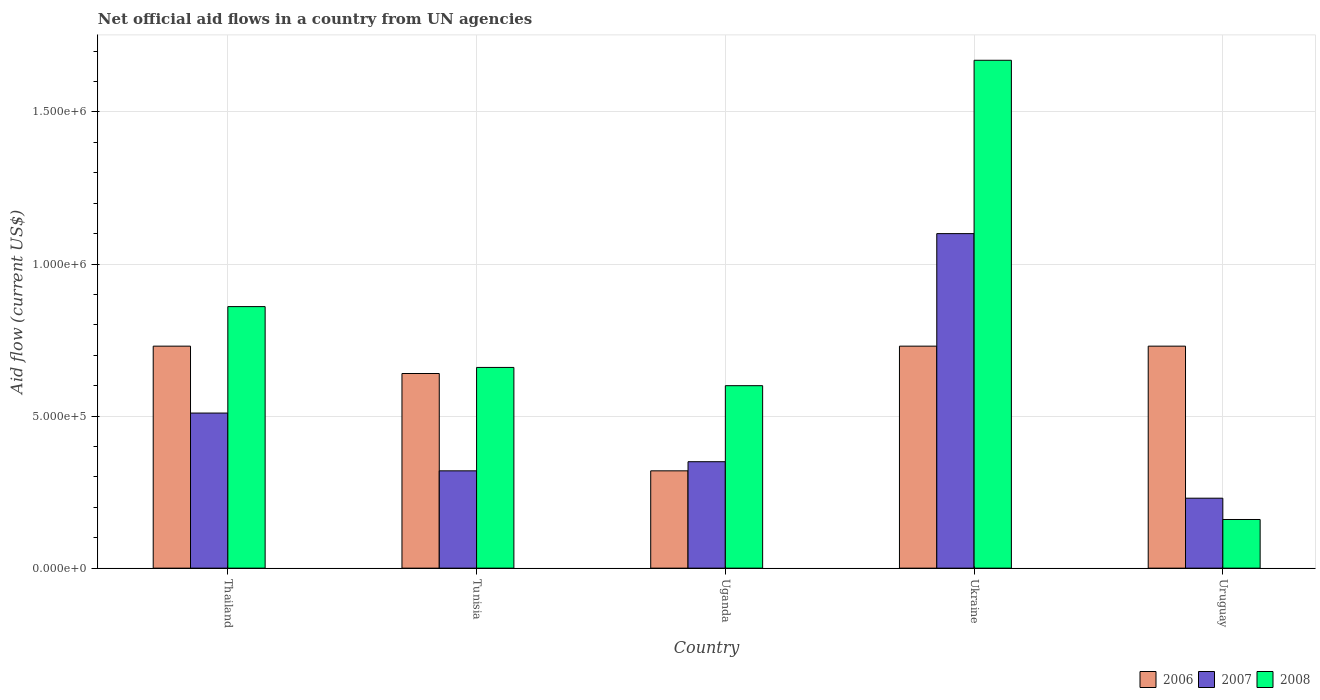How many different coloured bars are there?
Make the answer very short. 3. How many groups of bars are there?
Your response must be concise. 5. Are the number of bars on each tick of the X-axis equal?
Make the answer very short. Yes. How many bars are there on the 4th tick from the right?
Ensure brevity in your answer.  3. What is the label of the 1st group of bars from the left?
Give a very brief answer. Thailand. In how many cases, is the number of bars for a given country not equal to the number of legend labels?
Keep it short and to the point. 0. Across all countries, what is the maximum net official aid flow in 2006?
Provide a succinct answer. 7.30e+05. Across all countries, what is the minimum net official aid flow in 2007?
Provide a short and direct response. 2.30e+05. In which country was the net official aid flow in 2008 maximum?
Ensure brevity in your answer.  Ukraine. In which country was the net official aid flow in 2007 minimum?
Make the answer very short. Uruguay. What is the total net official aid flow in 2006 in the graph?
Your answer should be very brief. 3.15e+06. What is the difference between the net official aid flow in 2007 in Uganda and that in Ukraine?
Your answer should be very brief. -7.50e+05. What is the difference between the net official aid flow in 2008 in Ukraine and the net official aid flow in 2006 in Uganda?
Ensure brevity in your answer.  1.35e+06. What is the average net official aid flow in 2006 per country?
Your response must be concise. 6.30e+05. Is the net official aid flow in 2008 in Uganda less than that in Uruguay?
Offer a terse response. No. What is the difference between the highest and the second highest net official aid flow in 2008?
Provide a succinct answer. 1.01e+06. Is the sum of the net official aid flow in 2008 in Thailand and Tunisia greater than the maximum net official aid flow in 2006 across all countries?
Ensure brevity in your answer.  Yes. What does the 1st bar from the right in Thailand represents?
Offer a very short reply. 2008. How many bars are there?
Provide a succinct answer. 15. Are all the bars in the graph horizontal?
Your answer should be compact. No. What is the difference between two consecutive major ticks on the Y-axis?
Ensure brevity in your answer.  5.00e+05. Are the values on the major ticks of Y-axis written in scientific E-notation?
Make the answer very short. Yes. Does the graph contain any zero values?
Ensure brevity in your answer.  No. Does the graph contain grids?
Offer a terse response. Yes. What is the title of the graph?
Your answer should be very brief. Net official aid flows in a country from UN agencies. What is the label or title of the X-axis?
Make the answer very short. Country. What is the label or title of the Y-axis?
Offer a very short reply. Aid flow (current US$). What is the Aid flow (current US$) in 2006 in Thailand?
Your answer should be very brief. 7.30e+05. What is the Aid flow (current US$) of 2007 in Thailand?
Provide a succinct answer. 5.10e+05. What is the Aid flow (current US$) of 2008 in Thailand?
Give a very brief answer. 8.60e+05. What is the Aid flow (current US$) of 2006 in Tunisia?
Your response must be concise. 6.40e+05. What is the Aid flow (current US$) of 2007 in Tunisia?
Your response must be concise. 3.20e+05. What is the Aid flow (current US$) in 2008 in Tunisia?
Your answer should be compact. 6.60e+05. What is the Aid flow (current US$) of 2007 in Uganda?
Make the answer very short. 3.50e+05. What is the Aid flow (current US$) in 2006 in Ukraine?
Your answer should be very brief. 7.30e+05. What is the Aid flow (current US$) of 2007 in Ukraine?
Provide a succinct answer. 1.10e+06. What is the Aid flow (current US$) of 2008 in Ukraine?
Offer a terse response. 1.67e+06. What is the Aid flow (current US$) of 2006 in Uruguay?
Provide a succinct answer. 7.30e+05. What is the Aid flow (current US$) in 2007 in Uruguay?
Offer a terse response. 2.30e+05. What is the Aid flow (current US$) of 2008 in Uruguay?
Give a very brief answer. 1.60e+05. Across all countries, what is the maximum Aid flow (current US$) of 2006?
Provide a short and direct response. 7.30e+05. Across all countries, what is the maximum Aid flow (current US$) of 2007?
Offer a very short reply. 1.10e+06. Across all countries, what is the maximum Aid flow (current US$) in 2008?
Give a very brief answer. 1.67e+06. Across all countries, what is the minimum Aid flow (current US$) in 2008?
Offer a very short reply. 1.60e+05. What is the total Aid flow (current US$) of 2006 in the graph?
Provide a succinct answer. 3.15e+06. What is the total Aid flow (current US$) in 2007 in the graph?
Give a very brief answer. 2.51e+06. What is the total Aid flow (current US$) of 2008 in the graph?
Offer a very short reply. 3.95e+06. What is the difference between the Aid flow (current US$) in 2006 in Thailand and that in Tunisia?
Give a very brief answer. 9.00e+04. What is the difference between the Aid flow (current US$) of 2007 in Thailand and that in Tunisia?
Keep it short and to the point. 1.90e+05. What is the difference between the Aid flow (current US$) in 2008 in Thailand and that in Tunisia?
Provide a short and direct response. 2.00e+05. What is the difference between the Aid flow (current US$) in 2007 in Thailand and that in Uganda?
Your answer should be compact. 1.60e+05. What is the difference between the Aid flow (current US$) of 2008 in Thailand and that in Uganda?
Provide a short and direct response. 2.60e+05. What is the difference between the Aid flow (current US$) in 2006 in Thailand and that in Ukraine?
Provide a short and direct response. 0. What is the difference between the Aid flow (current US$) in 2007 in Thailand and that in Ukraine?
Offer a terse response. -5.90e+05. What is the difference between the Aid flow (current US$) of 2008 in Thailand and that in Ukraine?
Give a very brief answer. -8.10e+05. What is the difference between the Aid flow (current US$) in 2008 in Thailand and that in Uruguay?
Give a very brief answer. 7.00e+05. What is the difference between the Aid flow (current US$) in 2006 in Tunisia and that in Uganda?
Give a very brief answer. 3.20e+05. What is the difference between the Aid flow (current US$) of 2007 in Tunisia and that in Uganda?
Make the answer very short. -3.00e+04. What is the difference between the Aid flow (current US$) of 2007 in Tunisia and that in Ukraine?
Ensure brevity in your answer.  -7.80e+05. What is the difference between the Aid flow (current US$) in 2008 in Tunisia and that in Ukraine?
Make the answer very short. -1.01e+06. What is the difference between the Aid flow (current US$) of 2007 in Tunisia and that in Uruguay?
Ensure brevity in your answer.  9.00e+04. What is the difference between the Aid flow (current US$) in 2006 in Uganda and that in Ukraine?
Provide a short and direct response. -4.10e+05. What is the difference between the Aid flow (current US$) of 2007 in Uganda and that in Ukraine?
Give a very brief answer. -7.50e+05. What is the difference between the Aid flow (current US$) of 2008 in Uganda and that in Ukraine?
Make the answer very short. -1.07e+06. What is the difference between the Aid flow (current US$) of 2006 in Uganda and that in Uruguay?
Provide a short and direct response. -4.10e+05. What is the difference between the Aid flow (current US$) in 2008 in Uganda and that in Uruguay?
Provide a succinct answer. 4.40e+05. What is the difference between the Aid flow (current US$) of 2006 in Ukraine and that in Uruguay?
Your response must be concise. 0. What is the difference between the Aid flow (current US$) of 2007 in Ukraine and that in Uruguay?
Your response must be concise. 8.70e+05. What is the difference between the Aid flow (current US$) of 2008 in Ukraine and that in Uruguay?
Your answer should be very brief. 1.51e+06. What is the difference between the Aid flow (current US$) in 2006 in Thailand and the Aid flow (current US$) in 2007 in Tunisia?
Make the answer very short. 4.10e+05. What is the difference between the Aid flow (current US$) of 2007 in Thailand and the Aid flow (current US$) of 2008 in Tunisia?
Provide a short and direct response. -1.50e+05. What is the difference between the Aid flow (current US$) in 2006 in Thailand and the Aid flow (current US$) in 2008 in Uganda?
Give a very brief answer. 1.30e+05. What is the difference between the Aid flow (current US$) in 2006 in Thailand and the Aid flow (current US$) in 2007 in Ukraine?
Your answer should be very brief. -3.70e+05. What is the difference between the Aid flow (current US$) of 2006 in Thailand and the Aid flow (current US$) of 2008 in Ukraine?
Give a very brief answer. -9.40e+05. What is the difference between the Aid flow (current US$) of 2007 in Thailand and the Aid flow (current US$) of 2008 in Ukraine?
Keep it short and to the point. -1.16e+06. What is the difference between the Aid flow (current US$) of 2006 in Thailand and the Aid flow (current US$) of 2008 in Uruguay?
Your answer should be very brief. 5.70e+05. What is the difference between the Aid flow (current US$) of 2007 in Thailand and the Aid flow (current US$) of 2008 in Uruguay?
Ensure brevity in your answer.  3.50e+05. What is the difference between the Aid flow (current US$) in 2006 in Tunisia and the Aid flow (current US$) in 2008 in Uganda?
Your answer should be very brief. 4.00e+04. What is the difference between the Aid flow (current US$) of 2007 in Tunisia and the Aid flow (current US$) of 2008 in Uganda?
Provide a succinct answer. -2.80e+05. What is the difference between the Aid flow (current US$) in 2006 in Tunisia and the Aid flow (current US$) in 2007 in Ukraine?
Your response must be concise. -4.60e+05. What is the difference between the Aid flow (current US$) of 2006 in Tunisia and the Aid flow (current US$) of 2008 in Ukraine?
Provide a short and direct response. -1.03e+06. What is the difference between the Aid flow (current US$) in 2007 in Tunisia and the Aid flow (current US$) in 2008 in Ukraine?
Ensure brevity in your answer.  -1.35e+06. What is the difference between the Aid flow (current US$) of 2006 in Tunisia and the Aid flow (current US$) of 2007 in Uruguay?
Offer a terse response. 4.10e+05. What is the difference between the Aid flow (current US$) in 2006 in Tunisia and the Aid flow (current US$) in 2008 in Uruguay?
Give a very brief answer. 4.80e+05. What is the difference between the Aid flow (current US$) of 2006 in Uganda and the Aid flow (current US$) of 2007 in Ukraine?
Give a very brief answer. -7.80e+05. What is the difference between the Aid flow (current US$) of 2006 in Uganda and the Aid flow (current US$) of 2008 in Ukraine?
Your answer should be very brief. -1.35e+06. What is the difference between the Aid flow (current US$) in 2007 in Uganda and the Aid flow (current US$) in 2008 in Ukraine?
Make the answer very short. -1.32e+06. What is the difference between the Aid flow (current US$) of 2006 in Ukraine and the Aid flow (current US$) of 2008 in Uruguay?
Your answer should be very brief. 5.70e+05. What is the difference between the Aid flow (current US$) in 2007 in Ukraine and the Aid flow (current US$) in 2008 in Uruguay?
Your answer should be compact. 9.40e+05. What is the average Aid flow (current US$) of 2006 per country?
Your answer should be very brief. 6.30e+05. What is the average Aid flow (current US$) of 2007 per country?
Your answer should be very brief. 5.02e+05. What is the average Aid flow (current US$) of 2008 per country?
Provide a short and direct response. 7.90e+05. What is the difference between the Aid flow (current US$) of 2006 and Aid flow (current US$) of 2007 in Thailand?
Give a very brief answer. 2.20e+05. What is the difference between the Aid flow (current US$) of 2007 and Aid flow (current US$) of 2008 in Thailand?
Keep it short and to the point. -3.50e+05. What is the difference between the Aid flow (current US$) in 2006 and Aid flow (current US$) in 2007 in Tunisia?
Offer a terse response. 3.20e+05. What is the difference between the Aid flow (current US$) of 2006 and Aid flow (current US$) of 2008 in Tunisia?
Your answer should be compact. -2.00e+04. What is the difference between the Aid flow (current US$) of 2007 and Aid flow (current US$) of 2008 in Tunisia?
Provide a short and direct response. -3.40e+05. What is the difference between the Aid flow (current US$) in 2006 and Aid flow (current US$) in 2007 in Uganda?
Provide a succinct answer. -3.00e+04. What is the difference between the Aid flow (current US$) of 2006 and Aid flow (current US$) of 2008 in Uganda?
Your answer should be compact. -2.80e+05. What is the difference between the Aid flow (current US$) of 2006 and Aid flow (current US$) of 2007 in Ukraine?
Offer a terse response. -3.70e+05. What is the difference between the Aid flow (current US$) in 2006 and Aid flow (current US$) in 2008 in Ukraine?
Your answer should be very brief. -9.40e+05. What is the difference between the Aid flow (current US$) in 2007 and Aid flow (current US$) in 2008 in Ukraine?
Your answer should be very brief. -5.70e+05. What is the difference between the Aid flow (current US$) in 2006 and Aid flow (current US$) in 2007 in Uruguay?
Offer a terse response. 5.00e+05. What is the difference between the Aid flow (current US$) of 2006 and Aid flow (current US$) of 2008 in Uruguay?
Make the answer very short. 5.70e+05. What is the ratio of the Aid flow (current US$) in 2006 in Thailand to that in Tunisia?
Ensure brevity in your answer.  1.14. What is the ratio of the Aid flow (current US$) of 2007 in Thailand to that in Tunisia?
Your answer should be very brief. 1.59. What is the ratio of the Aid flow (current US$) of 2008 in Thailand to that in Tunisia?
Your answer should be compact. 1.3. What is the ratio of the Aid flow (current US$) of 2006 in Thailand to that in Uganda?
Ensure brevity in your answer.  2.28. What is the ratio of the Aid flow (current US$) of 2007 in Thailand to that in Uganda?
Your answer should be very brief. 1.46. What is the ratio of the Aid flow (current US$) of 2008 in Thailand to that in Uganda?
Your answer should be compact. 1.43. What is the ratio of the Aid flow (current US$) of 2006 in Thailand to that in Ukraine?
Your answer should be compact. 1. What is the ratio of the Aid flow (current US$) in 2007 in Thailand to that in Ukraine?
Provide a succinct answer. 0.46. What is the ratio of the Aid flow (current US$) in 2008 in Thailand to that in Ukraine?
Your answer should be very brief. 0.52. What is the ratio of the Aid flow (current US$) in 2007 in Thailand to that in Uruguay?
Offer a very short reply. 2.22. What is the ratio of the Aid flow (current US$) in 2008 in Thailand to that in Uruguay?
Offer a very short reply. 5.38. What is the ratio of the Aid flow (current US$) in 2006 in Tunisia to that in Uganda?
Your response must be concise. 2. What is the ratio of the Aid flow (current US$) in 2007 in Tunisia to that in Uganda?
Offer a terse response. 0.91. What is the ratio of the Aid flow (current US$) in 2008 in Tunisia to that in Uganda?
Ensure brevity in your answer.  1.1. What is the ratio of the Aid flow (current US$) in 2006 in Tunisia to that in Ukraine?
Provide a short and direct response. 0.88. What is the ratio of the Aid flow (current US$) of 2007 in Tunisia to that in Ukraine?
Keep it short and to the point. 0.29. What is the ratio of the Aid flow (current US$) of 2008 in Tunisia to that in Ukraine?
Your answer should be very brief. 0.4. What is the ratio of the Aid flow (current US$) in 2006 in Tunisia to that in Uruguay?
Ensure brevity in your answer.  0.88. What is the ratio of the Aid flow (current US$) of 2007 in Tunisia to that in Uruguay?
Your answer should be very brief. 1.39. What is the ratio of the Aid flow (current US$) of 2008 in Tunisia to that in Uruguay?
Your response must be concise. 4.12. What is the ratio of the Aid flow (current US$) in 2006 in Uganda to that in Ukraine?
Ensure brevity in your answer.  0.44. What is the ratio of the Aid flow (current US$) in 2007 in Uganda to that in Ukraine?
Make the answer very short. 0.32. What is the ratio of the Aid flow (current US$) in 2008 in Uganda to that in Ukraine?
Ensure brevity in your answer.  0.36. What is the ratio of the Aid flow (current US$) in 2006 in Uganda to that in Uruguay?
Your response must be concise. 0.44. What is the ratio of the Aid flow (current US$) of 2007 in Uganda to that in Uruguay?
Your response must be concise. 1.52. What is the ratio of the Aid flow (current US$) of 2008 in Uganda to that in Uruguay?
Provide a succinct answer. 3.75. What is the ratio of the Aid flow (current US$) in 2006 in Ukraine to that in Uruguay?
Offer a terse response. 1. What is the ratio of the Aid flow (current US$) of 2007 in Ukraine to that in Uruguay?
Offer a terse response. 4.78. What is the ratio of the Aid flow (current US$) of 2008 in Ukraine to that in Uruguay?
Keep it short and to the point. 10.44. What is the difference between the highest and the second highest Aid flow (current US$) in 2007?
Your answer should be compact. 5.90e+05. What is the difference between the highest and the second highest Aid flow (current US$) of 2008?
Provide a short and direct response. 8.10e+05. What is the difference between the highest and the lowest Aid flow (current US$) of 2007?
Make the answer very short. 8.70e+05. What is the difference between the highest and the lowest Aid flow (current US$) in 2008?
Offer a terse response. 1.51e+06. 